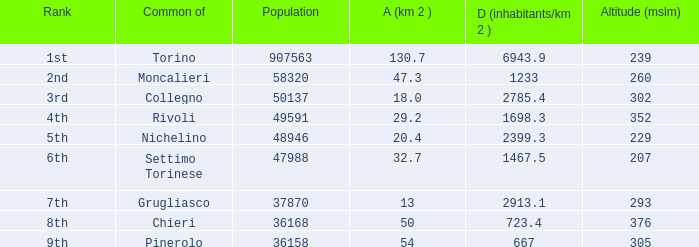How may population figures are given for Settimo Torinese 1.0. 